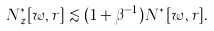Convert formula to latex. <formula><loc_0><loc_0><loc_500><loc_500>N _ { z } ^ { * } [ w , r ] \lesssim ( 1 + \beta ^ { - 1 } ) N _ { x } ^ { * } [ w , r ] .</formula> 